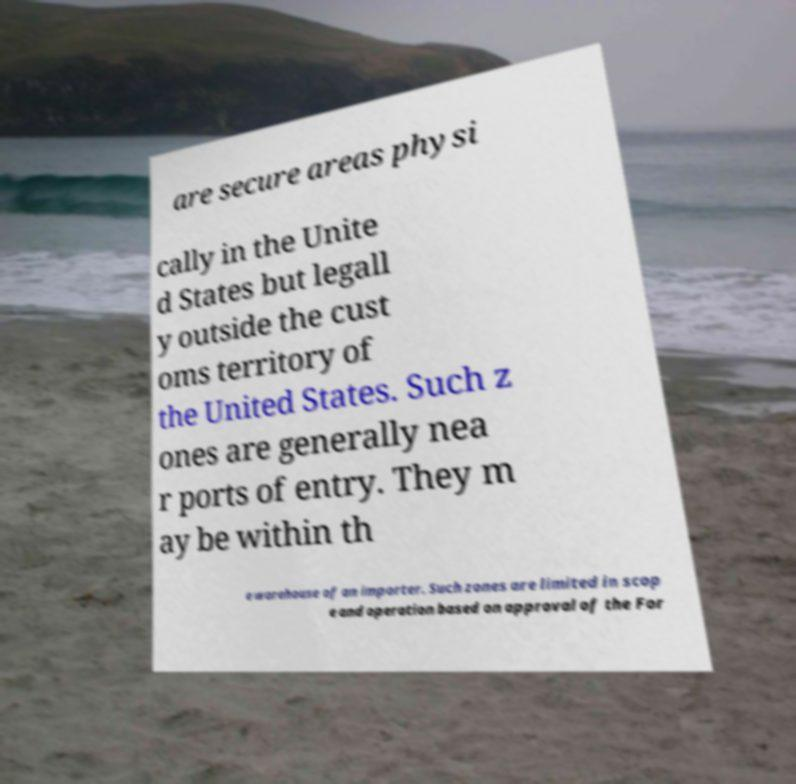I need the written content from this picture converted into text. Can you do that? are secure areas physi cally in the Unite d States but legall y outside the cust oms territory of the United States. Such z ones are generally nea r ports of entry. They m ay be within th e warehouse of an importer. Such zones are limited in scop e and operation based on approval of the For 